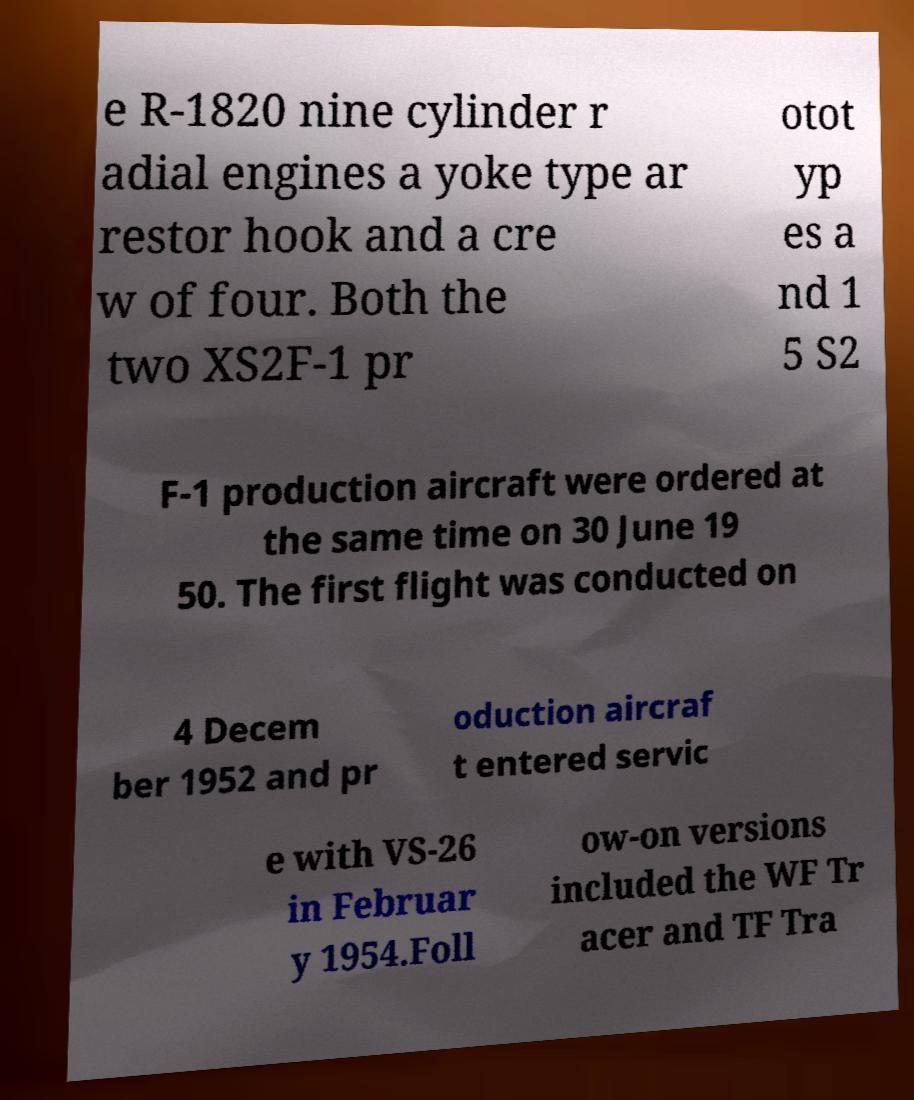I need the written content from this picture converted into text. Can you do that? e R-1820 nine cylinder r adial engines a yoke type ar restor hook and a cre w of four. Both the two XS2F-1 pr otot yp es a nd 1 5 S2 F-1 production aircraft were ordered at the same time on 30 June 19 50. The first flight was conducted on 4 Decem ber 1952 and pr oduction aircraf t entered servic e with VS-26 in Februar y 1954.Foll ow-on versions included the WF Tr acer and TF Tra 